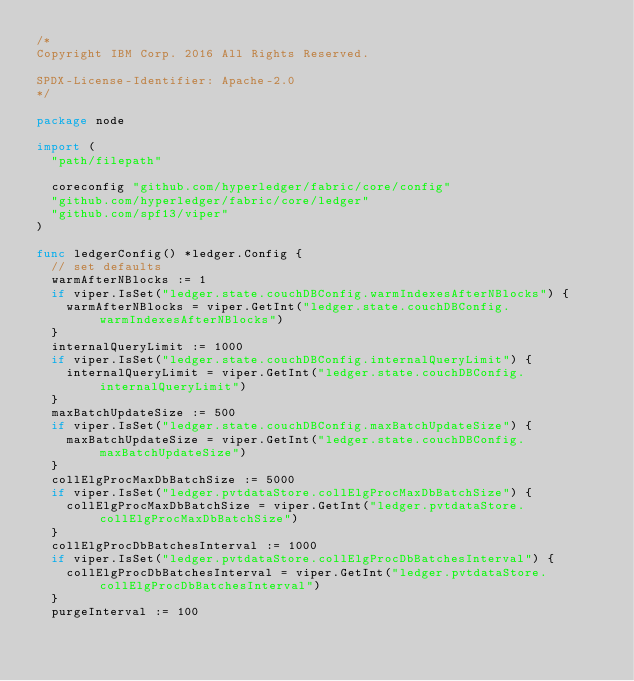<code> <loc_0><loc_0><loc_500><loc_500><_Go_>/*
Copyright IBM Corp. 2016 All Rights Reserved.

SPDX-License-Identifier: Apache-2.0
*/

package node

import (
	"path/filepath"

	coreconfig "github.com/hyperledger/fabric/core/config"
	"github.com/hyperledger/fabric/core/ledger"
	"github.com/spf13/viper"
)

func ledgerConfig() *ledger.Config {
	// set defaults
	warmAfterNBlocks := 1
	if viper.IsSet("ledger.state.couchDBConfig.warmIndexesAfterNBlocks") {
		warmAfterNBlocks = viper.GetInt("ledger.state.couchDBConfig.warmIndexesAfterNBlocks")
	}
	internalQueryLimit := 1000
	if viper.IsSet("ledger.state.couchDBConfig.internalQueryLimit") {
		internalQueryLimit = viper.GetInt("ledger.state.couchDBConfig.internalQueryLimit")
	}
	maxBatchUpdateSize := 500
	if viper.IsSet("ledger.state.couchDBConfig.maxBatchUpdateSize") {
		maxBatchUpdateSize = viper.GetInt("ledger.state.couchDBConfig.maxBatchUpdateSize")
	}
	collElgProcMaxDbBatchSize := 5000
	if viper.IsSet("ledger.pvtdataStore.collElgProcMaxDbBatchSize") {
		collElgProcMaxDbBatchSize = viper.GetInt("ledger.pvtdataStore.collElgProcMaxDbBatchSize")
	}
	collElgProcDbBatchesInterval := 1000
	if viper.IsSet("ledger.pvtdataStore.collElgProcDbBatchesInterval") {
		collElgProcDbBatchesInterval = viper.GetInt("ledger.pvtdataStore.collElgProcDbBatchesInterval")
	}
	purgeInterval := 100</code> 